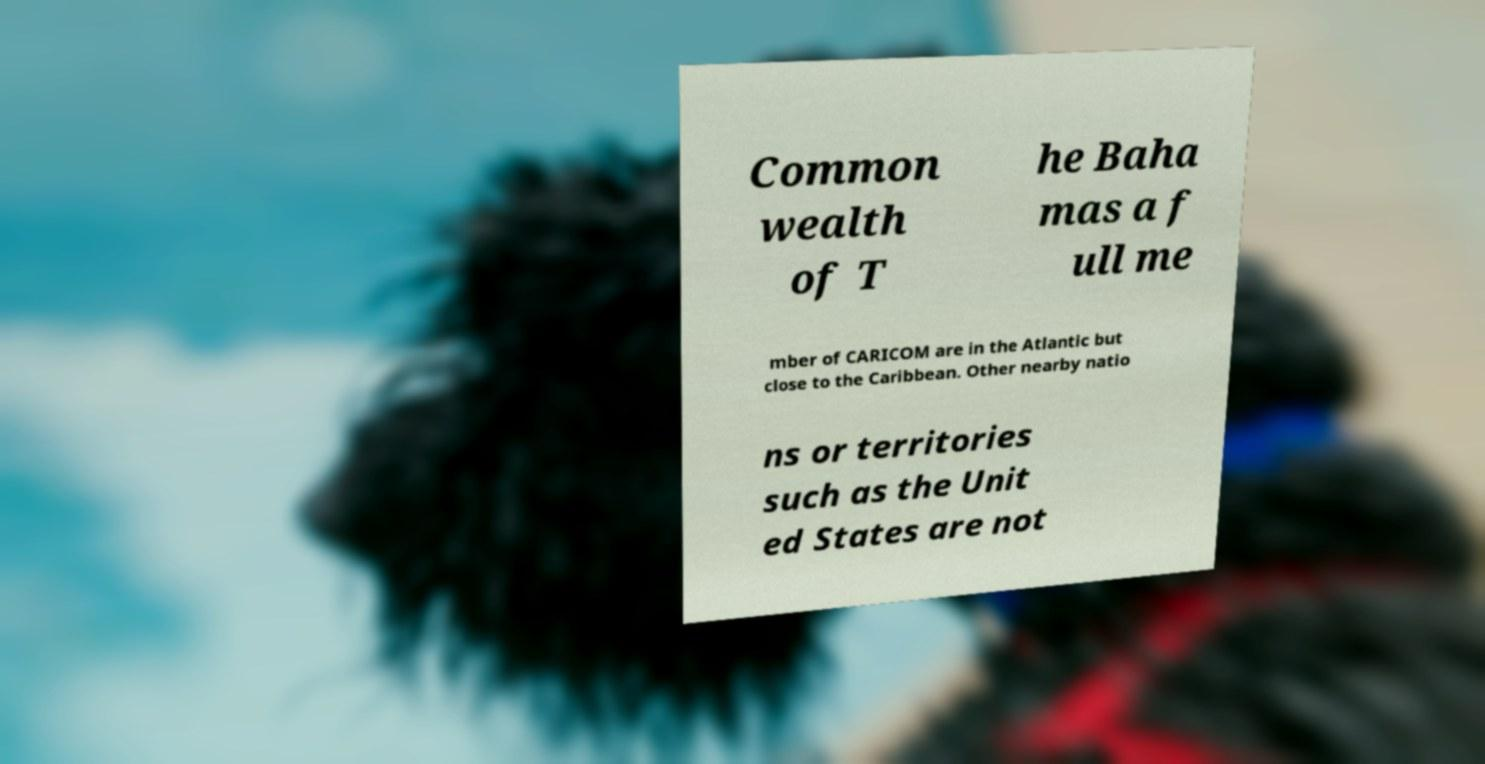Could you extract and type out the text from this image? Common wealth of T he Baha mas a f ull me mber of CARICOM are in the Atlantic but close to the Caribbean. Other nearby natio ns or territories such as the Unit ed States are not 